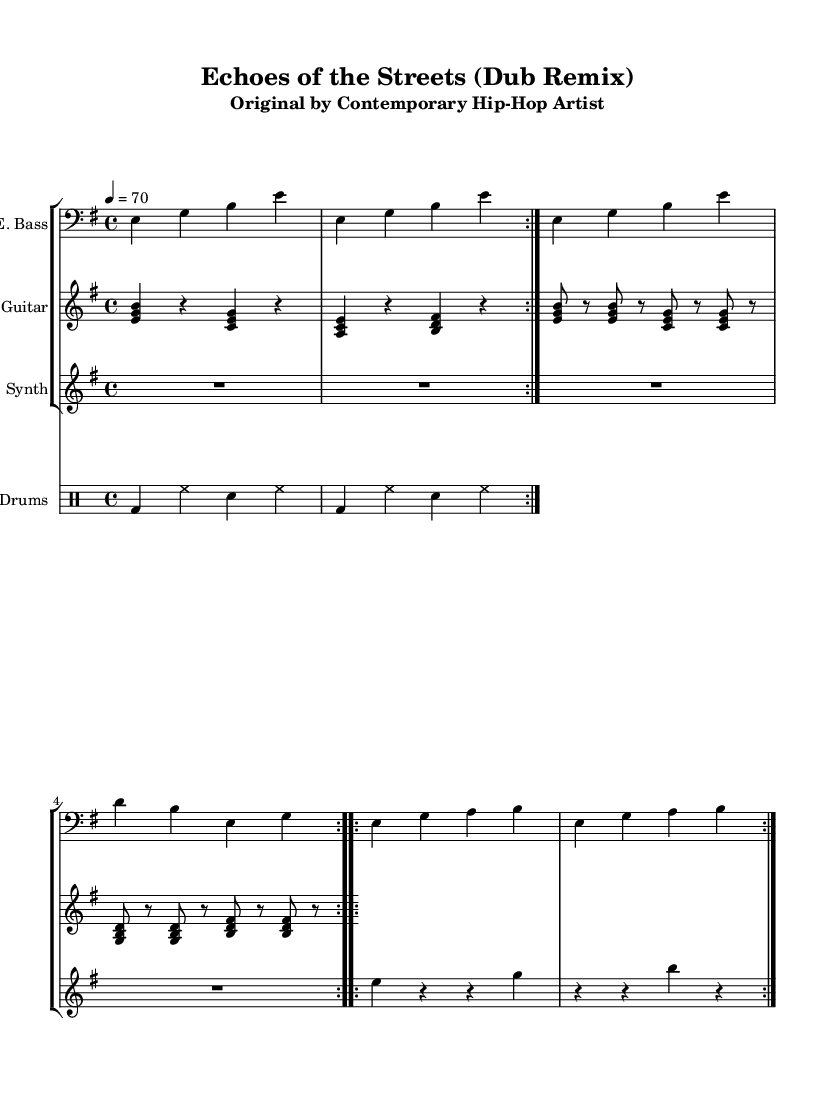What is the key signature of this music? The key signature is E minor, which has one sharp (F#). E minor is characterized by its relative minor relationship to G major, sharing the same key signature.
Answer: E minor What is the time signature of this music? The time signature is 4/4, indicating four beats per measure, which is common in many contemporary music genres, including reggae and hip-hop.
Answer: 4/4 What is the tempo of this piece? The tempo marking is indicated as 70 beats per minute, setting a moderate tempo for the performance. The tempo provides the speed at which the music should be played.
Answer: 70 How many times is the main bass line repeated? The main bass line is repeated twice according to the "volta 2" marking, which indicates sections that should be played two times.
Answer: 2 What type of instrument is featured in the first staff? The first staff features an electric bass, which is identified by the label "E. Bass" on the staff, and its clef also indicates that it plays lower frequencies typical of bass instruments.
Answer: Electric Bass What rhythmic pattern do the drums follow? The drums use a basic repeating pattern of bass and hi-hat hits in the notation, followed by snare hits, which is characteristic of reggae drumming styles. The repetition is noted as "volta 2," indicating it occurs multiple times.
Answer: Bass and hi-hat Which instrument adds melody and harmony above the bass? The electric guitar adds melody and harmony above the bass. The notation shows chords being played, which typically fulfills this role in reggae music, enhancing the overall groove.
Answer: Electric Guitar 